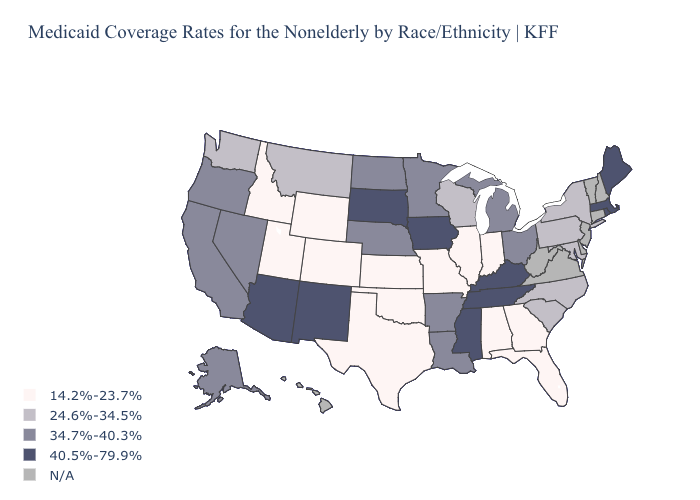Does Wyoming have the lowest value in the USA?
Give a very brief answer. Yes. Which states have the highest value in the USA?
Concise answer only. Arizona, Iowa, Kentucky, Maine, Massachusetts, Mississippi, New Mexico, Rhode Island, South Dakota, Tennessee. Name the states that have a value in the range 14.2%-23.7%?
Keep it brief. Alabama, Colorado, Florida, Georgia, Idaho, Illinois, Indiana, Kansas, Missouri, Oklahoma, Texas, Utah, Wyoming. Name the states that have a value in the range 14.2%-23.7%?
Answer briefly. Alabama, Colorado, Florida, Georgia, Idaho, Illinois, Indiana, Kansas, Missouri, Oklahoma, Texas, Utah, Wyoming. Which states have the lowest value in the Northeast?
Quick response, please. New York, Pennsylvania. What is the value of Nebraska?
Quick response, please. 34.7%-40.3%. What is the lowest value in states that border Rhode Island?
Keep it brief. 40.5%-79.9%. Which states hav the highest value in the South?
Quick response, please. Kentucky, Mississippi, Tennessee. Does Arizona have the highest value in the West?
Keep it brief. Yes. Among the states that border North Dakota , does Montana have the lowest value?
Short answer required. Yes. Does the map have missing data?
Quick response, please. Yes. Which states hav the highest value in the West?
Answer briefly. Arizona, New Mexico. Which states have the highest value in the USA?
Give a very brief answer. Arizona, Iowa, Kentucky, Maine, Massachusetts, Mississippi, New Mexico, Rhode Island, South Dakota, Tennessee. What is the highest value in the Northeast ?
Be succinct. 40.5%-79.9%. 